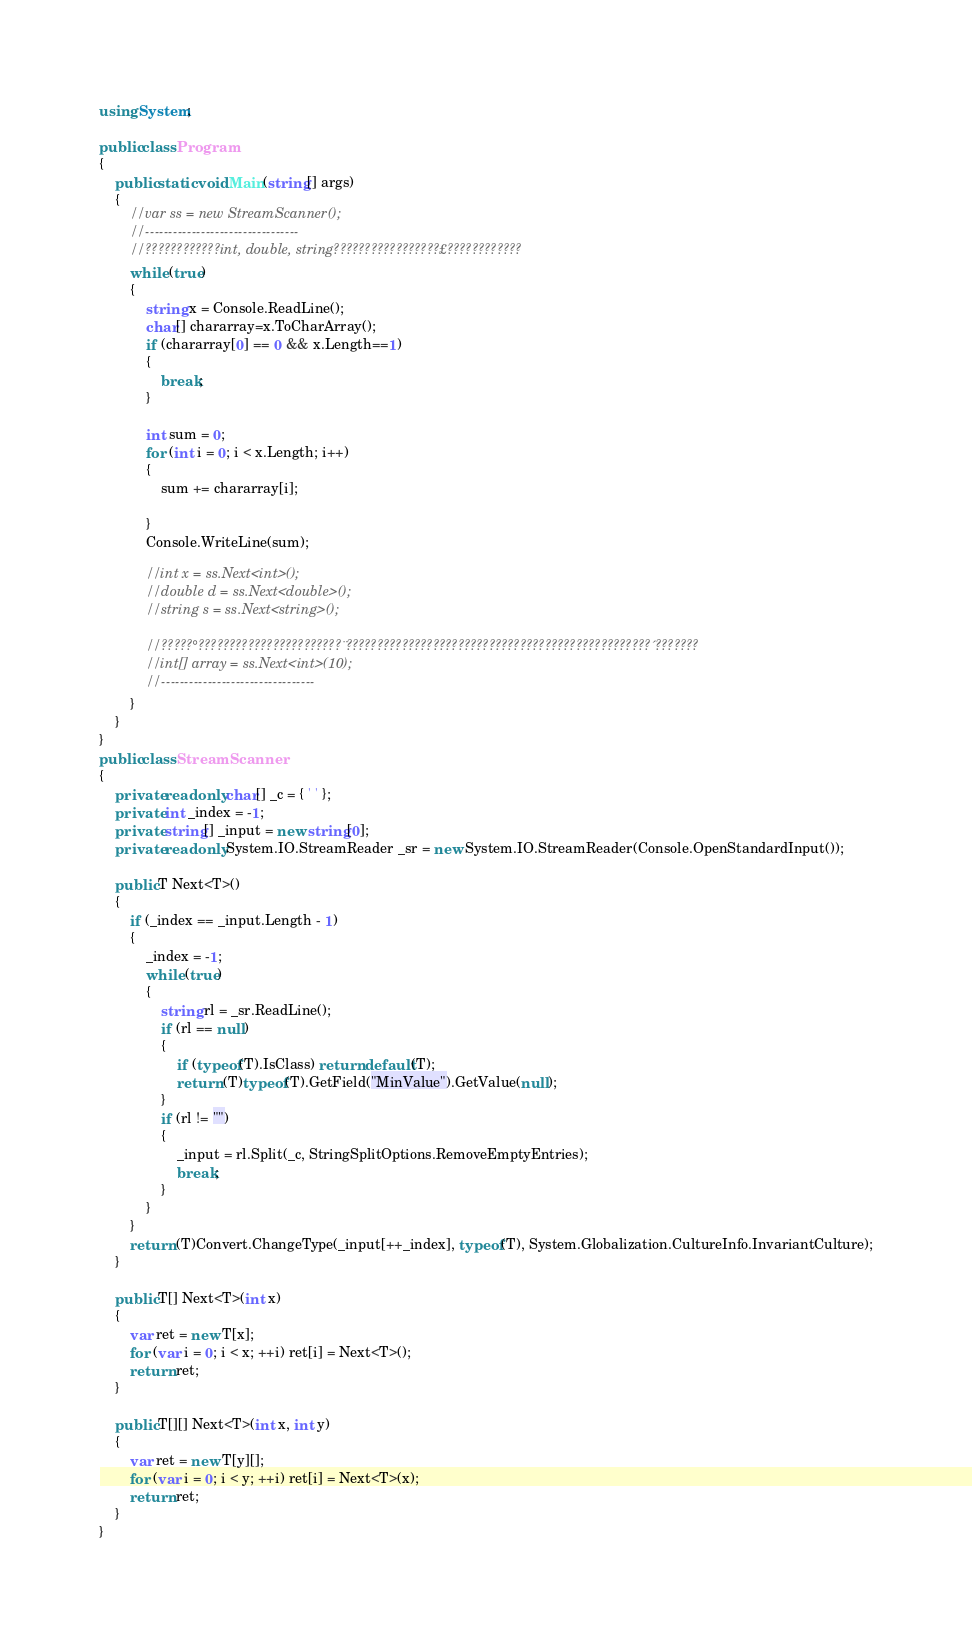<code> <loc_0><loc_0><loc_500><loc_500><_C#_>using System;

public class Program
{
	public static void Main(string[] args)
	{
		//var ss = new StreamScanner();
		//---------------------------------
		//????????????int, double, string?????????????????£????????????
		while (true)
		{
			string x = Console.ReadLine();
			char[] chararray=x.ToCharArray();
			if (chararray[0] == 0 && x.Length==1)
			{
				break;
			}

			int sum = 0;
			for (int i = 0; i < x.Length; i++)
			{
				sum += chararray[i];

			}
			Console.WriteLine(sum);

			//int x = ss.Next<int>();
			//double d = ss.Next<double>();
			//string s = ss.Next<string>();

			//?????°???????????????????????¨?????????????????????????????????????????????????´???????
			//int[] array = ss.Next<int>(10);
			//---------------------------------
		}
	}
}
public class StreamScanner
{
	private readonly char[] _c = { ' ' };
	private int _index = -1;
	private string[] _input = new string[0];
	private readonly System.IO.StreamReader _sr = new System.IO.StreamReader(Console.OpenStandardInput());

	public T Next<T>()
	{
		if (_index == _input.Length - 1)
		{
			_index = -1;
			while (true)
			{
				string rl = _sr.ReadLine();
				if (rl == null)
				{
					if (typeof(T).IsClass) return default(T);
					return (T)typeof(T).GetField("MinValue").GetValue(null);
				}
				if (rl != "")
				{
					_input = rl.Split(_c, StringSplitOptions.RemoveEmptyEntries);
					break;
				}
			}
		}
		return (T)Convert.ChangeType(_input[++_index], typeof(T), System.Globalization.CultureInfo.InvariantCulture);
	}

	public T[] Next<T>(int x)
	{
		var ret = new T[x];
		for (var i = 0; i < x; ++i) ret[i] = Next<T>();
		return ret;
	}

	public T[][] Next<T>(int x, int y)
	{
		var ret = new T[y][];
		for (var i = 0; i < y; ++i) ret[i] = Next<T>(x);
		return ret;
	}
}</code> 